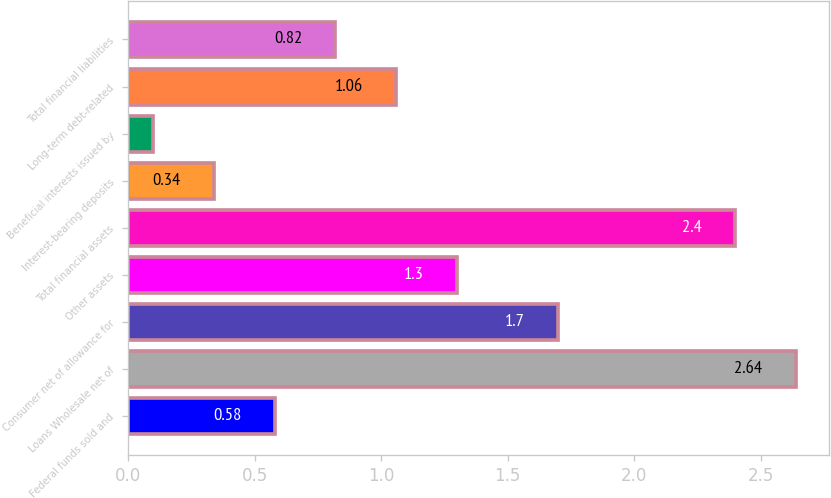<chart> <loc_0><loc_0><loc_500><loc_500><bar_chart><fcel>Federal funds sold and<fcel>Loans Wholesale net of<fcel>Consumer net of allowance for<fcel>Other assets<fcel>Total financial assets<fcel>Interest-bearing deposits<fcel>Beneficial interests issued by<fcel>Long-term debt-related<fcel>Total financial liabilities<nl><fcel>0.58<fcel>2.64<fcel>1.7<fcel>1.3<fcel>2.4<fcel>0.34<fcel>0.1<fcel>1.06<fcel>0.82<nl></chart> 